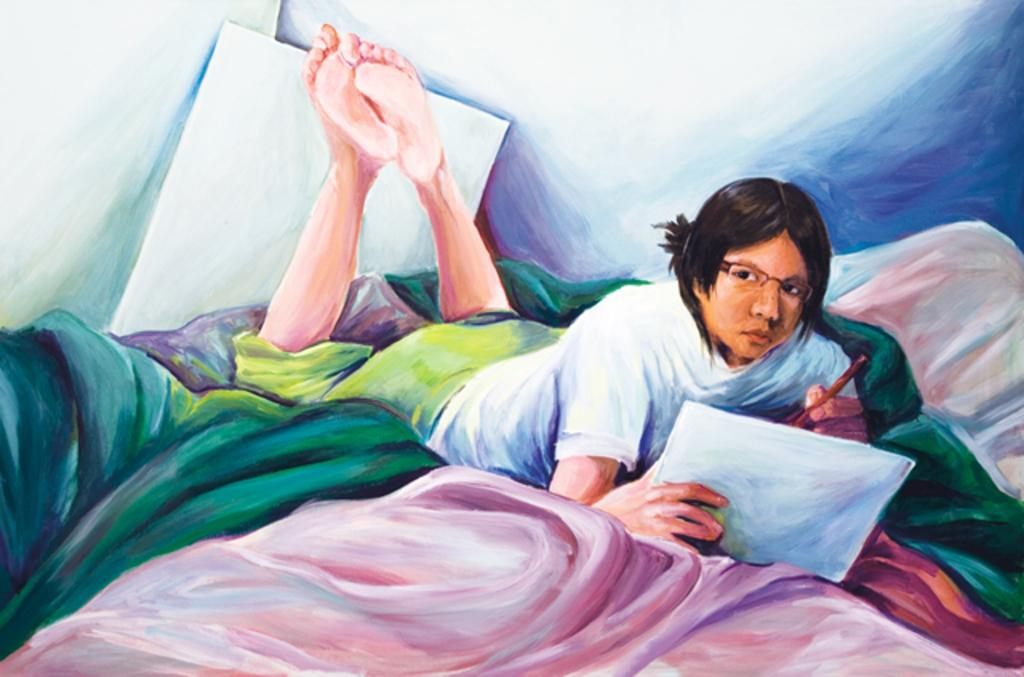What is depicted in the painting in the image? There is a painting of a person in the image. What is the person doing in the painting? The person is lying on clothes and holding a paper and pen. What can be seen in the background of the painting? There is a board and a wall in the background of the image. How many stars can be seen in the image? There are no stars visible in the image; it features a painting of a person lying on clothes and holding a paper and pen. What type of boundary is present in the image? There is no specific boundary mentioned in the image; it only shows a painting with a person, clothes, a paper, a pen, a board, and a wall in the background. 